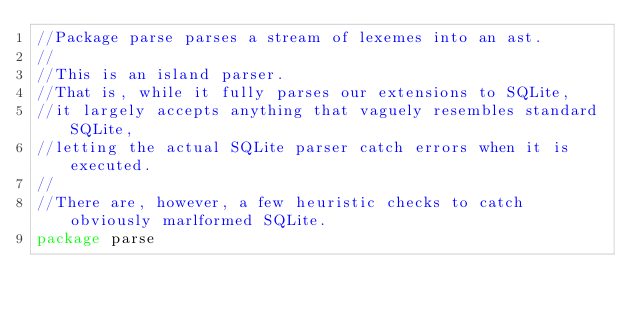<code> <loc_0><loc_0><loc_500><loc_500><_Go_>//Package parse parses a stream of lexemes into an ast.
//
//This is an island parser.
//That is, while it fully parses our extensions to SQLite,
//it largely accepts anything that vaguely resembles standard SQLite,
//letting the actual SQLite parser catch errors when it is executed.
//
//There are, however, a few heuristic checks to catch obviously marlformed SQLite.
package parse
</code> 